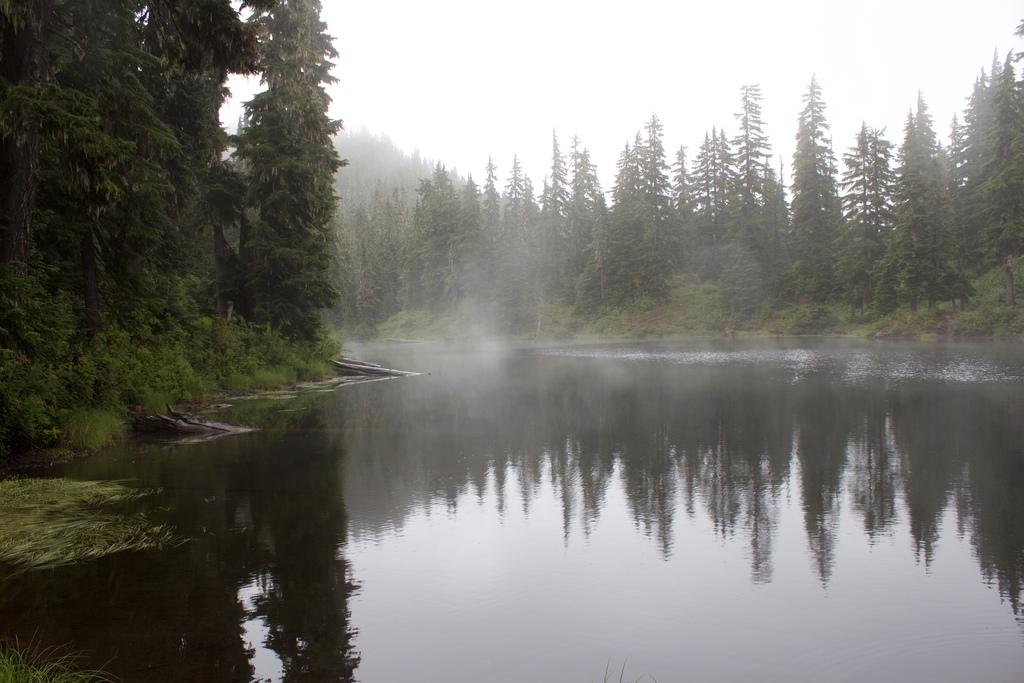What type of natural feature is present in the image? There is a river in the image. What can be seen in the background of the image? There are many trees in the background of the image. What is visible at the top of the image? The sky is visible at the top of the image. How many beads are floating on the river in the image? There are no beads present in the image; it only features a river, trees, and the sky. 